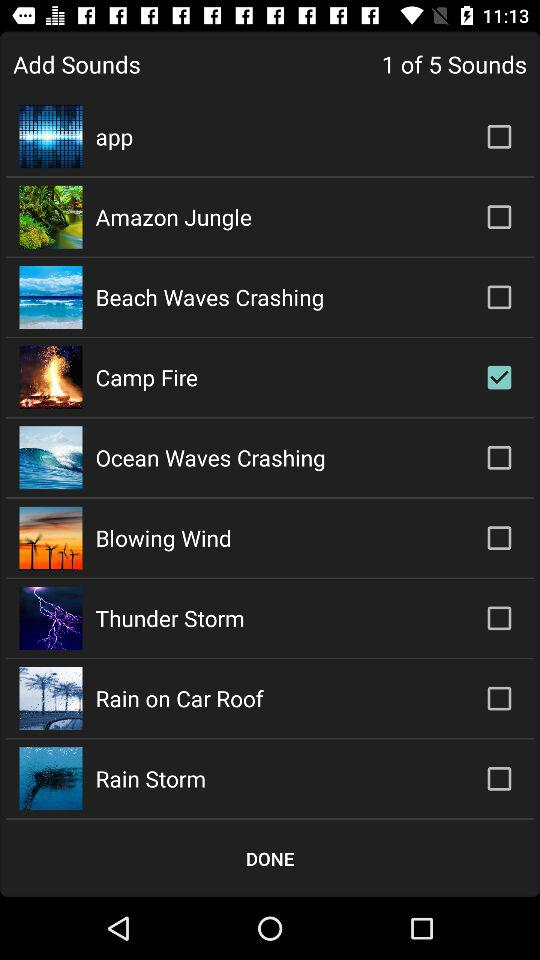What's the number of "Add Sounds"? The number is 5. 